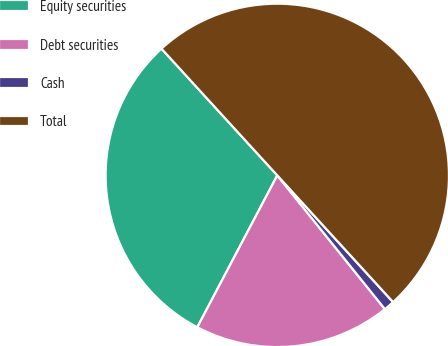Convert chart. <chart><loc_0><loc_0><loc_500><loc_500><pie_chart><fcel>Equity securities<fcel>Debt securities<fcel>Cash<fcel>Total<nl><fcel>30.5%<fcel>18.5%<fcel>1.0%<fcel>50.0%<nl></chart> 